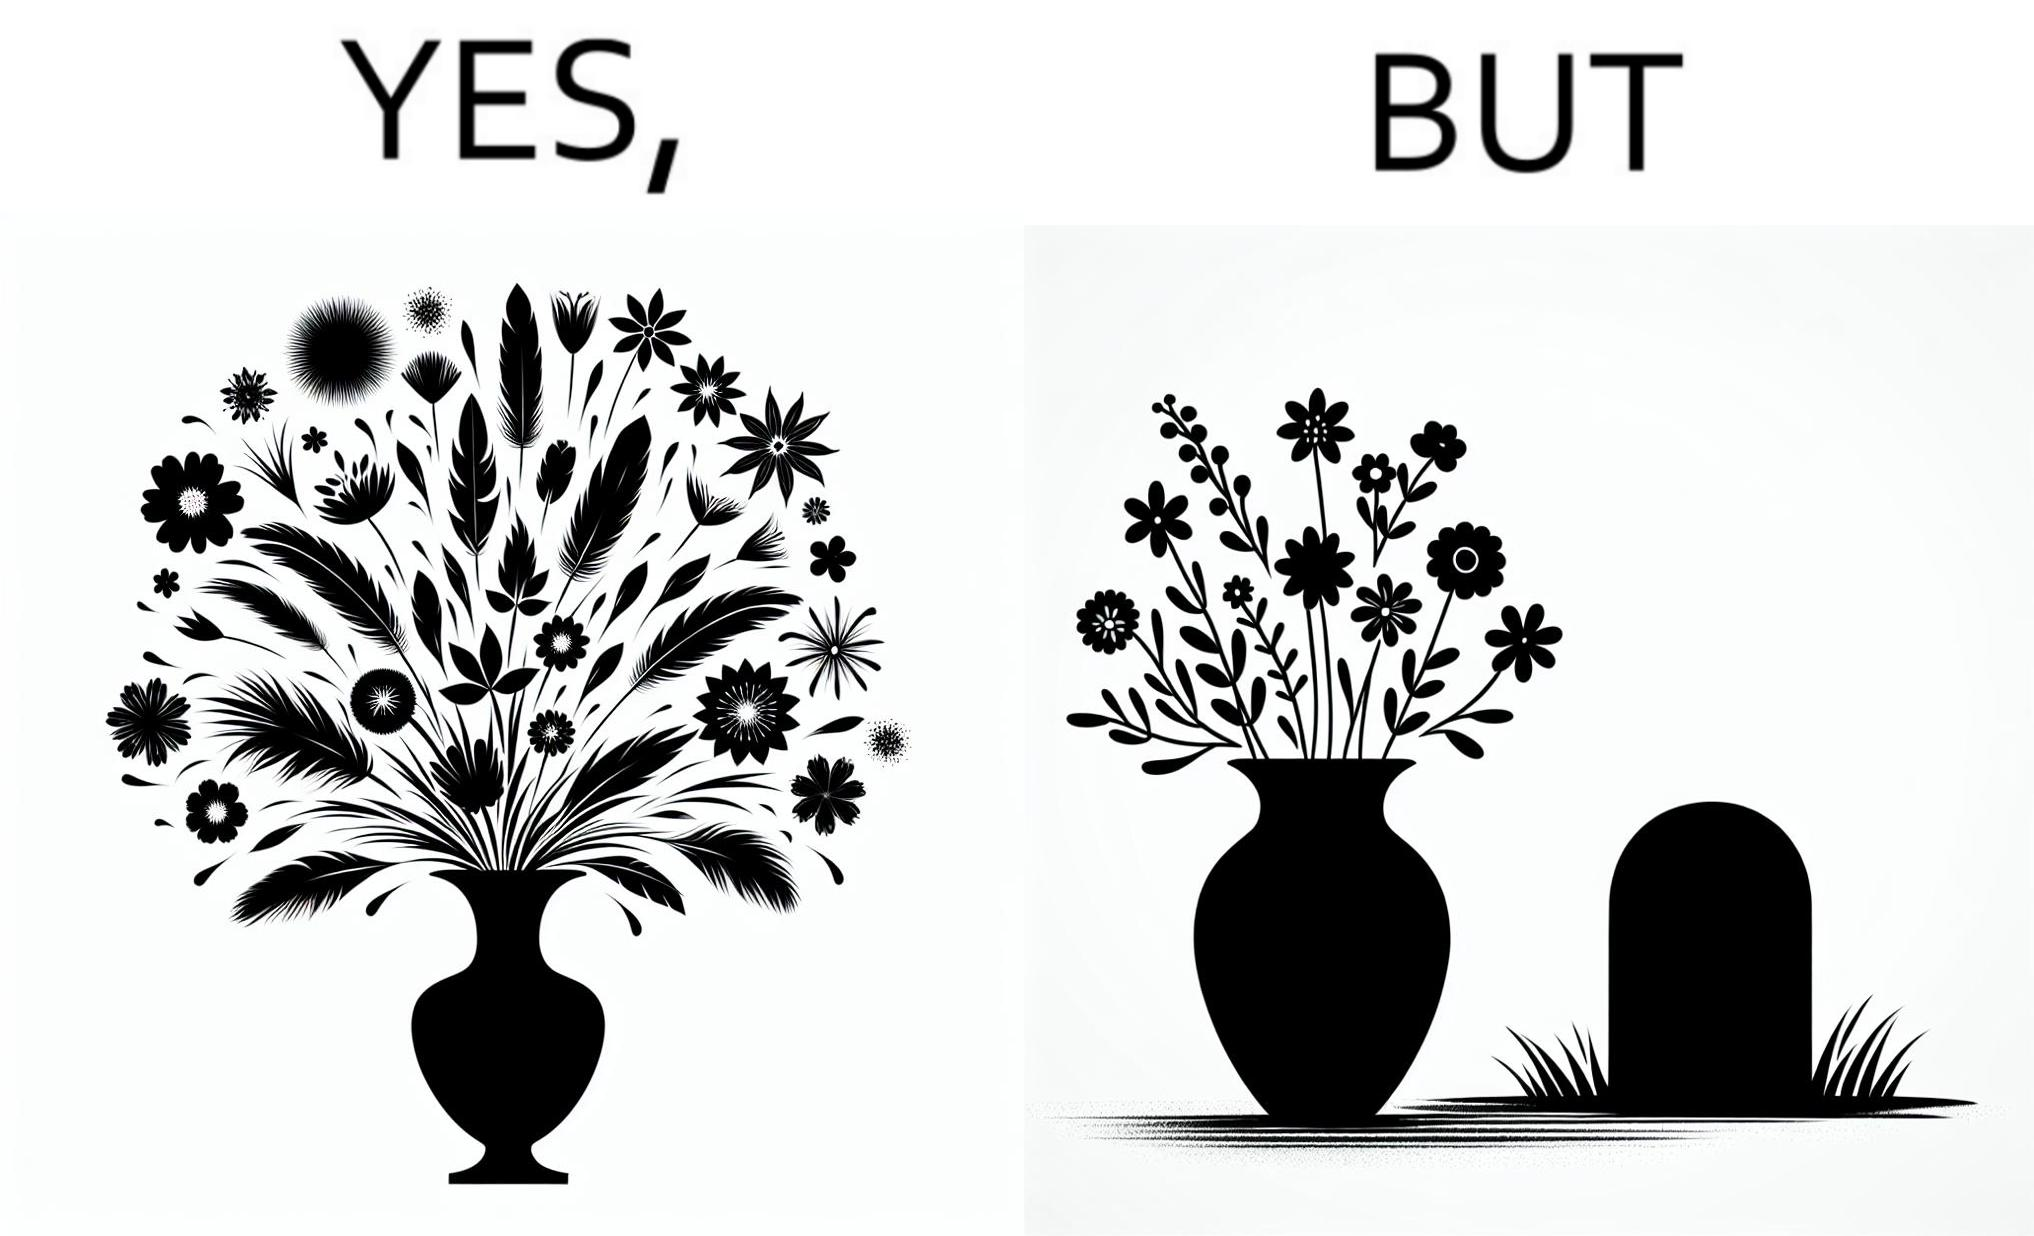What is the satirical meaning behind this image? The image is ironic, because in the first image a vase full of different beautiful flowers is seen which spreads a feeling of positivity, cheerfulness etc., whereas in the second image when the same vase is put in front of a grave stone it produces a feeling of sorrow 